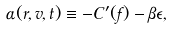Convert formula to latex. <formula><loc_0><loc_0><loc_500><loc_500>\alpha ( { r } , { v } , t ) \equiv - C ^ { \prime } ( f ) - \beta \epsilon ,</formula> 